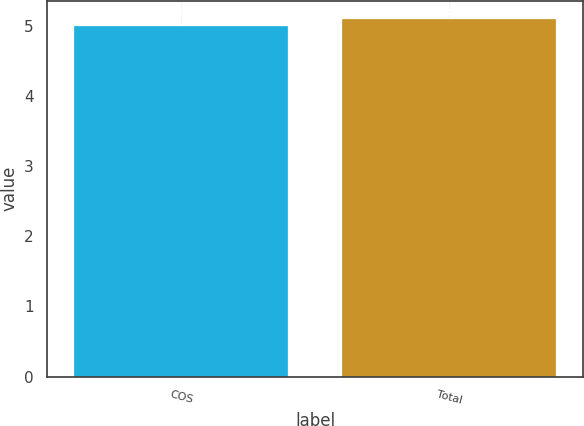Convert chart to OTSL. <chart><loc_0><loc_0><loc_500><loc_500><bar_chart><fcel>COS<fcel>Total<nl><fcel>5<fcel>5.1<nl></chart> 